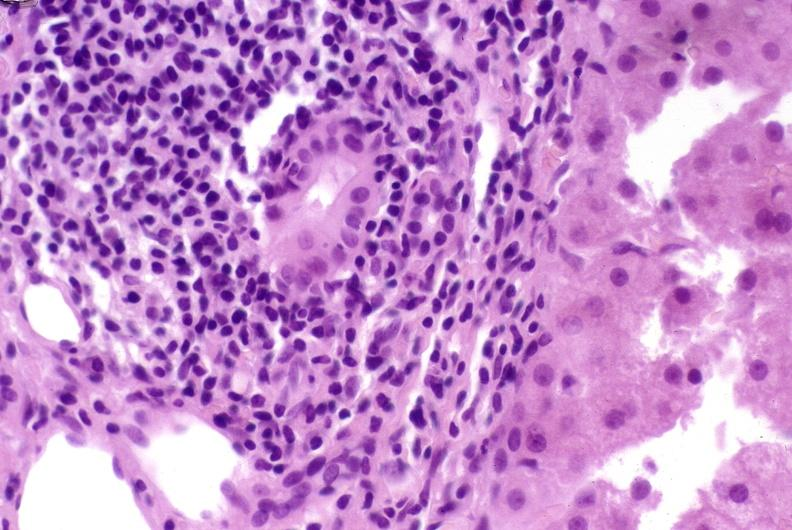what does this image show?
Answer the question using a single word or phrase. Post-orthotopic liver transplant 